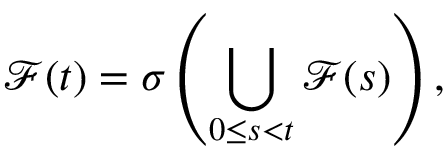<formula> <loc_0><loc_0><loc_500><loc_500>{ \mathcal { F } } ( t ) = \sigma \left ( \bigcup _ { 0 \leq s < t } { \mathcal { F } } ( s ) \right ) ,</formula> 